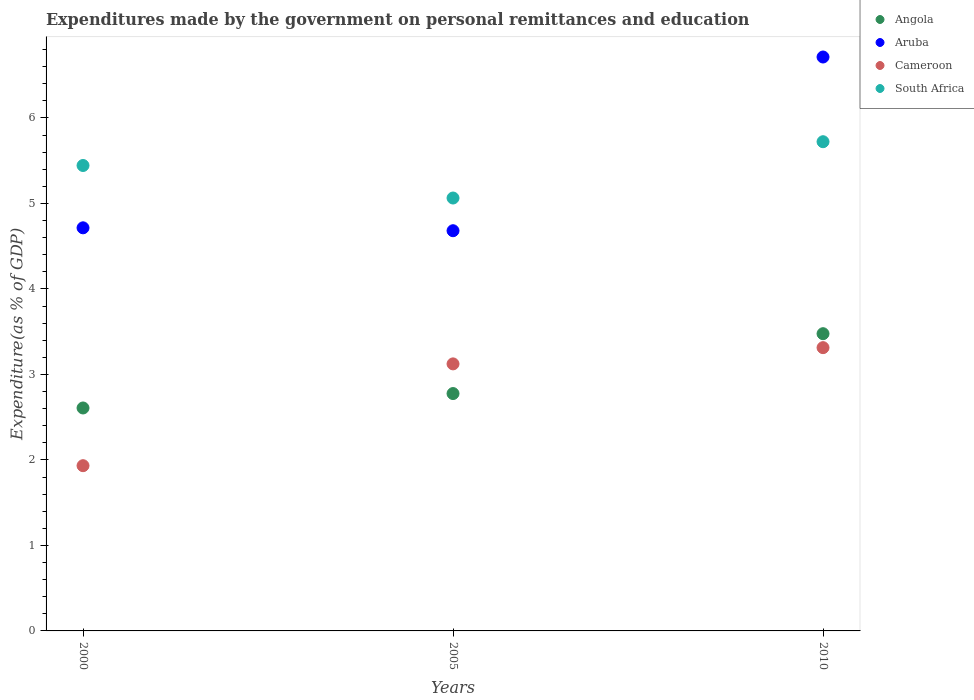Is the number of dotlines equal to the number of legend labels?
Your answer should be very brief. Yes. What is the expenditures made by the government on personal remittances and education in Cameroon in 2010?
Your response must be concise. 3.31. Across all years, what is the maximum expenditures made by the government on personal remittances and education in Cameroon?
Give a very brief answer. 3.31. Across all years, what is the minimum expenditures made by the government on personal remittances and education in Cameroon?
Ensure brevity in your answer.  1.93. In which year was the expenditures made by the government on personal remittances and education in South Africa minimum?
Your response must be concise. 2005. What is the total expenditures made by the government on personal remittances and education in Angola in the graph?
Keep it short and to the point. 8.86. What is the difference between the expenditures made by the government on personal remittances and education in Aruba in 2005 and that in 2010?
Your response must be concise. -2.03. What is the difference between the expenditures made by the government on personal remittances and education in Angola in 2005 and the expenditures made by the government on personal remittances and education in Aruba in 2010?
Keep it short and to the point. -3.94. What is the average expenditures made by the government on personal remittances and education in South Africa per year?
Ensure brevity in your answer.  5.41. In the year 2000, what is the difference between the expenditures made by the government on personal remittances and education in Angola and expenditures made by the government on personal remittances and education in Cameroon?
Offer a terse response. 0.67. What is the ratio of the expenditures made by the government on personal remittances and education in Aruba in 2000 to that in 2005?
Provide a short and direct response. 1.01. Is the expenditures made by the government on personal remittances and education in South Africa in 2000 less than that in 2005?
Give a very brief answer. No. Is the difference between the expenditures made by the government on personal remittances and education in Angola in 2005 and 2010 greater than the difference between the expenditures made by the government on personal remittances and education in Cameroon in 2005 and 2010?
Give a very brief answer. No. What is the difference between the highest and the second highest expenditures made by the government on personal remittances and education in Cameroon?
Keep it short and to the point. 0.19. What is the difference between the highest and the lowest expenditures made by the government on personal remittances and education in Angola?
Ensure brevity in your answer.  0.87. Is the sum of the expenditures made by the government on personal remittances and education in Angola in 2005 and 2010 greater than the maximum expenditures made by the government on personal remittances and education in Cameroon across all years?
Your response must be concise. Yes. Is it the case that in every year, the sum of the expenditures made by the government on personal remittances and education in South Africa and expenditures made by the government on personal remittances and education in Angola  is greater than the expenditures made by the government on personal remittances and education in Aruba?
Provide a short and direct response. Yes. Does the expenditures made by the government on personal remittances and education in South Africa monotonically increase over the years?
Offer a very short reply. No. What is the difference between two consecutive major ticks on the Y-axis?
Provide a short and direct response. 1. Are the values on the major ticks of Y-axis written in scientific E-notation?
Give a very brief answer. No. Does the graph contain any zero values?
Your response must be concise. No. Does the graph contain grids?
Your response must be concise. No. Where does the legend appear in the graph?
Provide a short and direct response. Top right. What is the title of the graph?
Your response must be concise. Expenditures made by the government on personal remittances and education. What is the label or title of the Y-axis?
Provide a succinct answer. Expenditure(as % of GDP). What is the Expenditure(as % of GDP) in Angola in 2000?
Give a very brief answer. 2.61. What is the Expenditure(as % of GDP) in Aruba in 2000?
Give a very brief answer. 4.71. What is the Expenditure(as % of GDP) of Cameroon in 2000?
Make the answer very short. 1.93. What is the Expenditure(as % of GDP) of South Africa in 2000?
Keep it short and to the point. 5.44. What is the Expenditure(as % of GDP) of Angola in 2005?
Provide a succinct answer. 2.78. What is the Expenditure(as % of GDP) of Aruba in 2005?
Give a very brief answer. 4.68. What is the Expenditure(as % of GDP) in Cameroon in 2005?
Your answer should be very brief. 3.12. What is the Expenditure(as % of GDP) in South Africa in 2005?
Ensure brevity in your answer.  5.06. What is the Expenditure(as % of GDP) of Angola in 2010?
Keep it short and to the point. 3.48. What is the Expenditure(as % of GDP) in Aruba in 2010?
Offer a very short reply. 6.71. What is the Expenditure(as % of GDP) in Cameroon in 2010?
Your answer should be very brief. 3.31. What is the Expenditure(as % of GDP) in South Africa in 2010?
Offer a terse response. 5.72. Across all years, what is the maximum Expenditure(as % of GDP) in Angola?
Your answer should be compact. 3.48. Across all years, what is the maximum Expenditure(as % of GDP) of Aruba?
Offer a terse response. 6.71. Across all years, what is the maximum Expenditure(as % of GDP) in Cameroon?
Provide a succinct answer. 3.31. Across all years, what is the maximum Expenditure(as % of GDP) of South Africa?
Provide a succinct answer. 5.72. Across all years, what is the minimum Expenditure(as % of GDP) of Angola?
Your response must be concise. 2.61. Across all years, what is the minimum Expenditure(as % of GDP) in Aruba?
Keep it short and to the point. 4.68. Across all years, what is the minimum Expenditure(as % of GDP) in Cameroon?
Provide a short and direct response. 1.93. Across all years, what is the minimum Expenditure(as % of GDP) of South Africa?
Your response must be concise. 5.06. What is the total Expenditure(as % of GDP) of Angola in the graph?
Offer a terse response. 8.86. What is the total Expenditure(as % of GDP) of Aruba in the graph?
Ensure brevity in your answer.  16.11. What is the total Expenditure(as % of GDP) of Cameroon in the graph?
Offer a terse response. 8.37. What is the total Expenditure(as % of GDP) of South Africa in the graph?
Keep it short and to the point. 16.23. What is the difference between the Expenditure(as % of GDP) of Angola in 2000 and that in 2005?
Your answer should be compact. -0.17. What is the difference between the Expenditure(as % of GDP) of Aruba in 2000 and that in 2005?
Offer a terse response. 0.03. What is the difference between the Expenditure(as % of GDP) of Cameroon in 2000 and that in 2005?
Your answer should be very brief. -1.19. What is the difference between the Expenditure(as % of GDP) in South Africa in 2000 and that in 2005?
Make the answer very short. 0.38. What is the difference between the Expenditure(as % of GDP) of Angola in 2000 and that in 2010?
Your answer should be very brief. -0.87. What is the difference between the Expenditure(as % of GDP) in Aruba in 2000 and that in 2010?
Provide a short and direct response. -2. What is the difference between the Expenditure(as % of GDP) in Cameroon in 2000 and that in 2010?
Offer a very short reply. -1.38. What is the difference between the Expenditure(as % of GDP) in South Africa in 2000 and that in 2010?
Your answer should be compact. -0.28. What is the difference between the Expenditure(as % of GDP) of Angola in 2005 and that in 2010?
Keep it short and to the point. -0.7. What is the difference between the Expenditure(as % of GDP) in Aruba in 2005 and that in 2010?
Your answer should be compact. -2.03. What is the difference between the Expenditure(as % of GDP) of Cameroon in 2005 and that in 2010?
Give a very brief answer. -0.19. What is the difference between the Expenditure(as % of GDP) of South Africa in 2005 and that in 2010?
Provide a short and direct response. -0.66. What is the difference between the Expenditure(as % of GDP) in Angola in 2000 and the Expenditure(as % of GDP) in Aruba in 2005?
Your answer should be compact. -2.07. What is the difference between the Expenditure(as % of GDP) of Angola in 2000 and the Expenditure(as % of GDP) of Cameroon in 2005?
Provide a short and direct response. -0.52. What is the difference between the Expenditure(as % of GDP) of Angola in 2000 and the Expenditure(as % of GDP) of South Africa in 2005?
Ensure brevity in your answer.  -2.46. What is the difference between the Expenditure(as % of GDP) of Aruba in 2000 and the Expenditure(as % of GDP) of Cameroon in 2005?
Your answer should be very brief. 1.59. What is the difference between the Expenditure(as % of GDP) of Aruba in 2000 and the Expenditure(as % of GDP) of South Africa in 2005?
Give a very brief answer. -0.35. What is the difference between the Expenditure(as % of GDP) in Cameroon in 2000 and the Expenditure(as % of GDP) in South Africa in 2005?
Make the answer very short. -3.13. What is the difference between the Expenditure(as % of GDP) of Angola in 2000 and the Expenditure(as % of GDP) of Aruba in 2010?
Provide a short and direct response. -4.11. What is the difference between the Expenditure(as % of GDP) of Angola in 2000 and the Expenditure(as % of GDP) of Cameroon in 2010?
Make the answer very short. -0.71. What is the difference between the Expenditure(as % of GDP) of Angola in 2000 and the Expenditure(as % of GDP) of South Africa in 2010?
Your answer should be compact. -3.11. What is the difference between the Expenditure(as % of GDP) in Aruba in 2000 and the Expenditure(as % of GDP) in Cameroon in 2010?
Give a very brief answer. 1.4. What is the difference between the Expenditure(as % of GDP) of Aruba in 2000 and the Expenditure(as % of GDP) of South Africa in 2010?
Give a very brief answer. -1.01. What is the difference between the Expenditure(as % of GDP) in Cameroon in 2000 and the Expenditure(as % of GDP) in South Africa in 2010?
Provide a short and direct response. -3.79. What is the difference between the Expenditure(as % of GDP) of Angola in 2005 and the Expenditure(as % of GDP) of Aruba in 2010?
Ensure brevity in your answer.  -3.94. What is the difference between the Expenditure(as % of GDP) of Angola in 2005 and the Expenditure(as % of GDP) of Cameroon in 2010?
Provide a succinct answer. -0.54. What is the difference between the Expenditure(as % of GDP) of Angola in 2005 and the Expenditure(as % of GDP) of South Africa in 2010?
Ensure brevity in your answer.  -2.95. What is the difference between the Expenditure(as % of GDP) in Aruba in 2005 and the Expenditure(as % of GDP) in Cameroon in 2010?
Offer a terse response. 1.37. What is the difference between the Expenditure(as % of GDP) of Aruba in 2005 and the Expenditure(as % of GDP) of South Africa in 2010?
Keep it short and to the point. -1.04. What is the difference between the Expenditure(as % of GDP) of Cameroon in 2005 and the Expenditure(as % of GDP) of South Africa in 2010?
Offer a terse response. -2.6. What is the average Expenditure(as % of GDP) in Angola per year?
Offer a very short reply. 2.95. What is the average Expenditure(as % of GDP) in Aruba per year?
Your response must be concise. 5.37. What is the average Expenditure(as % of GDP) in Cameroon per year?
Your response must be concise. 2.79. What is the average Expenditure(as % of GDP) in South Africa per year?
Give a very brief answer. 5.41. In the year 2000, what is the difference between the Expenditure(as % of GDP) in Angola and Expenditure(as % of GDP) in Aruba?
Offer a terse response. -2.11. In the year 2000, what is the difference between the Expenditure(as % of GDP) in Angola and Expenditure(as % of GDP) in Cameroon?
Provide a succinct answer. 0.68. In the year 2000, what is the difference between the Expenditure(as % of GDP) of Angola and Expenditure(as % of GDP) of South Africa?
Your answer should be compact. -2.84. In the year 2000, what is the difference between the Expenditure(as % of GDP) of Aruba and Expenditure(as % of GDP) of Cameroon?
Offer a very short reply. 2.78. In the year 2000, what is the difference between the Expenditure(as % of GDP) in Aruba and Expenditure(as % of GDP) in South Africa?
Provide a short and direct response. -0.73. In the year 2000, what is the difference between the Expenditure(as % of GDP) in Cameroon and Expenditure(as % of GDP) in South Africa?
Offer a terse response. -3.51. In the year 2005, what is the difference between the Expenditure(as % of GDP) in Angola and Expenditure(as % of GDP) in Aruba?
Provide a short and direct response. -1.9. In the year 2005, what is the difference between the Expenditure(as % of GDP) in Angola and Expenditure(as % of GDP) in Cameroon?
Provide a succinct answer. -0.35. In the year 2005, what is the difference between the Expenditure(as % of GDP) in Angola and Expenditure(as % of GDP) in South Africa?
Offer a very short reply. -2.29. In the year 2005, what is the difference between the Expenditure(as % of GDP) in Aruba and Expenditure(as % of GDP) in Cameroon?
Offer a very short reply. 1.56. In the year 2005, what is the difference between the Expenditure(as % of GDP) of Aruba and Expenditure(as % of GDP) of South Africa?
Provide a short and direct response. -0.38. In the year 2005, what is the difference between the Expenditure(as % of GDP) of Cameroon and Expenditure(as % of GDP) of South Africa?
Give a very brief answer. -1.94. In the year 2010, what is the difference between the Expenditure(as % of GDP) in Angola and Expenditure(as % of GDP) in Aruba?
Provide a short and direct response. -3.24. In the year 2010, what is the difference between the Expenditure(as % of GDP) in Angola and Expenditure(as % of GDP) in Cameroon?
Make the answer very short. 0.16. In the year 2010, what is the difference between the Expenditure(as % of GDP) in Angola and Expenditure(as % of GDP) in South Africa?
Ensure brevity in your answer.  -2.25. In the year 2010, what is the difference between the Expenditure(as % of GDP) of Aruba and Expenditure(as % of GDP) of Cameroon?
Make the answer very short. 3.4. In the year 2010, what is the difference between the Expenditure(as % of GDP) of Cameroon and Expenditure(as % of GDP) of South Africa?
Ensure brevity in your answer.  -2.41. What is the ratio of the Expenditure(as % of GDP) of Angola in 2000 to that in 2005?
Give a very brief answer. 0.94. What is the ratio of the Expenditure(as % of GDP) in Cameroon in 2000 to that in 2005?
Ensure brevity in your answer.  0.62. What is the ratio of the Expenditure(as % of GDP) in South Africa in 2000 to that in 2005?
Your response must be concise. 1.08. What is the ratio of the Expenditure(as % of GDP) in Angola in 2000 to that in 2010?
Your answer should be very brief. 0.75. What is the ratio of the Expenditure(as % of GDP) in Aruba in 2000 to that in 2010?
Your answer should be compact. 0.7. What is the ratio of the Expenditure(as % of GDP) of Cameroon in 2000 to that in 2010?
Your answer should be compact. 0.58. What is the ratio of the Expenditure(as % of GDP) of South Africa in 2000 to that in 2010?
Provide a succinct answer. 0.95. What is the ratio of the Expenditure(as % of GDP) of Angola in 2005 to that in 2010?
Ensure brevity in your answer.  0.8. What is the ratio of the Expenditure(as % of GDP) of Aruba in 2005 to that in 2010?
Your answer should be compact. 0.7. What is the ratio of the Expenditure(as % of GDP) of Cameroon in 2005 to that in 2010?
Your answer should be compact. 0.94. What is the ratio of the Expenditure(as % of GDP) in South Africa in 2005 to that in 2010?
Keep it short and to the point. 0.88. What is the difference between the highest and the second highest Expenditure(as % of GDP) in Angola?
Your response must be concise. 0.7. What is the difference between the highest and the second highest Expenditure(as % of GDP) of Aruba?
Keep it short and to the point. 2. What is the difference between the highest and the second highest Expenditure(as % of GDP) in Cameroon?
Provide a short and direct response. 0.19. What is the difference between the highest and the second highest Expenditure(as % of GDP) in South Africa?
Your answer should be compact. 0.28. What is the difference between the highest and the lowest Expenditure(as % of GDP) in Angola?
Ensure brevity in your answer.  0.87. What is the difference between the highest and the lowest Expenditure(as % of GDP) of Aruba?
Ensure brevity in your answer.  2.03. What is the difference between the highest and the lowest Expenditure(as % of GDP) of Cameroon?
Provide a succinct answer. 1.38. What is the difference between the highest and the lowest Expenditure(as % of GDP) of South Africa?
Your answer should be very brief. 0.66. 